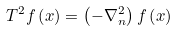Convert formula to latex. <formula><loc_0><loc_0><loc_500><loc_500>T ^ { 2 } f \left ( x \right ) = \left ( - \nabla _ { n } ^ { 2 } \right ) f \left ( x \right )</formula> 